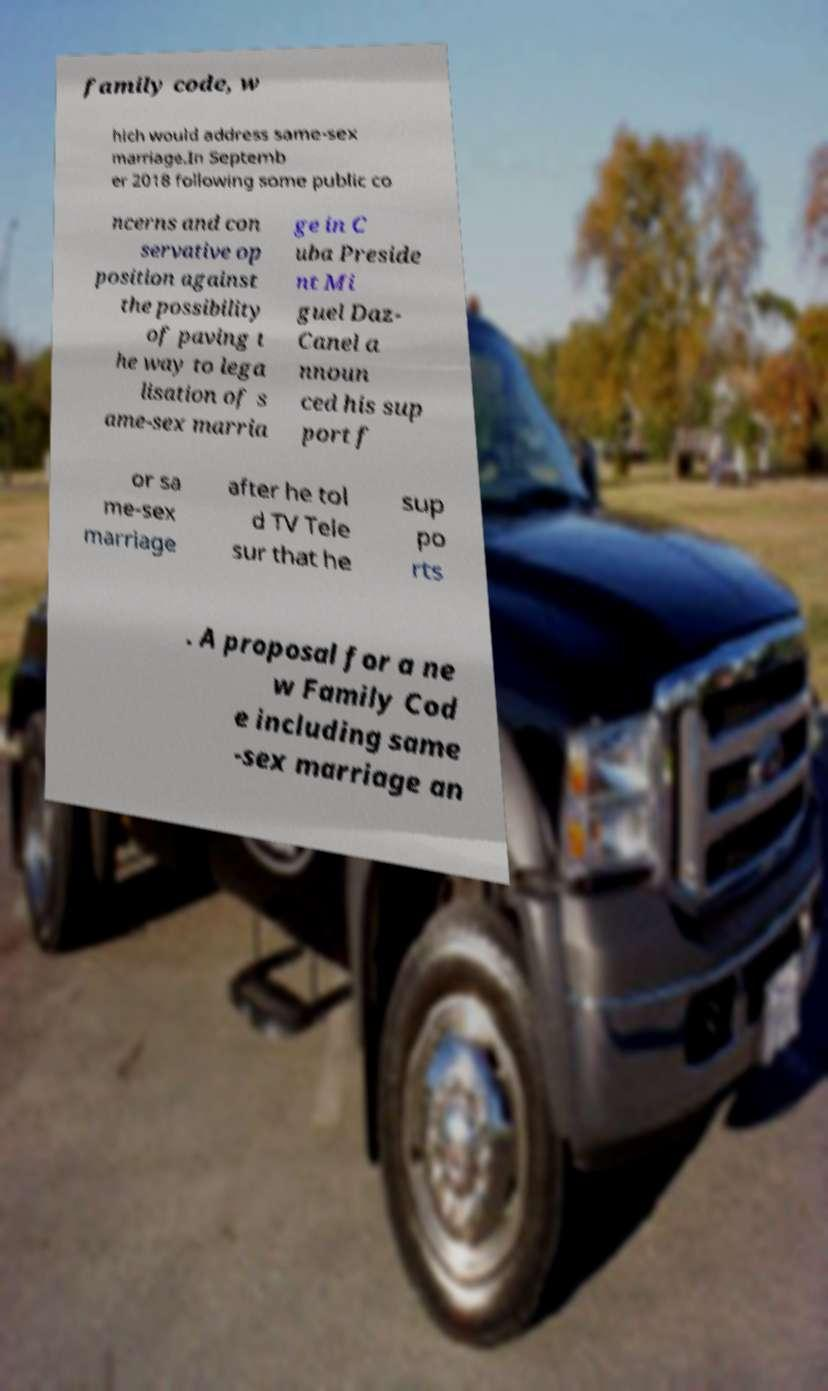There's text embedded in this image that I need extracted. Can you transcribe it verbatim? family code, w hich would address same-sex marriage.In Septemb er 2018 following some public co ncerns and con servative op position against the possibility of paving t he way to lega lisation of s ame-sex marria ge in C uba Preside nt Mi guel Daz- Canel a nnoun ced his sup port f or sa me-sex marriage after he tol d TV Tele sur that he sup po rts . A proposal for a ne w Family Cod e including same -sex marriage an 